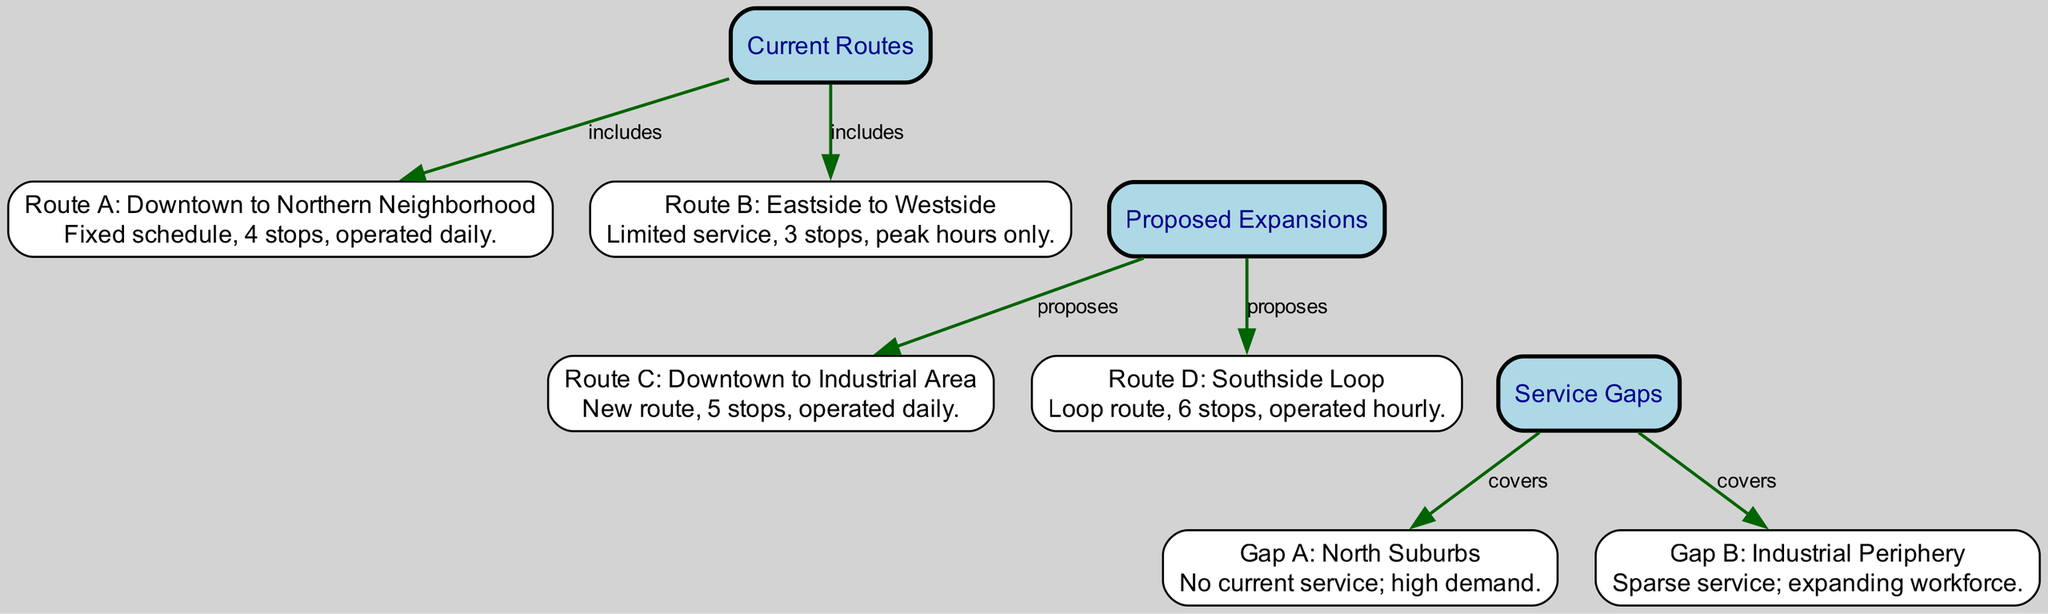What are the current routes in the public transportation network? The diagram specifically lists two current routes: Route A and Route B under the "Current Routes" node.
Answer: Route A and Route B How many proposed expansions are listed in the diagram? The diagram features two proposed expansions: Route C and Route D under the "Proposed Expansions" node.
Answer: 2 What service gaps are identified in the town? The diagram notes two service gaps: Gap A and Gap B under the "Service Gaps" node.
Answer: Gap A and Gap B Which route is proposed to connect Downtown to the Industrial Area? The "Proposed Expansions" section indicates that Route C is the proposed connection from Downtown to the Industrial Area.
Answer: Route C What is the frequency of service for Route D? The diagram states that Route D operates hourly, emphasizing its regular frequency compared to other routes.
Answer: Hourly What is the demand situation in the North Suburbs? The diagram shows that Gap A in the North Suburbs has no current service but indicates a high demand for public transportation.
Answer: High demand Which current route operates only during peak hours? According to the diagram, Route B serves the Eastside to Westside connection and is noted for its limited service during peak hours only.
Answer: Route B What type of service is proposed for the Southside Loop? The diagram specifies that Route D, proposed for the Southside Loop, includes 6 stops and operates hourly, indicating a structured service.
Answer: Loop route How many stops does Route A include? The description for Route A clearly states that it has 4 stops, making it straightforward to determine from the diagram.
Answer: 4 